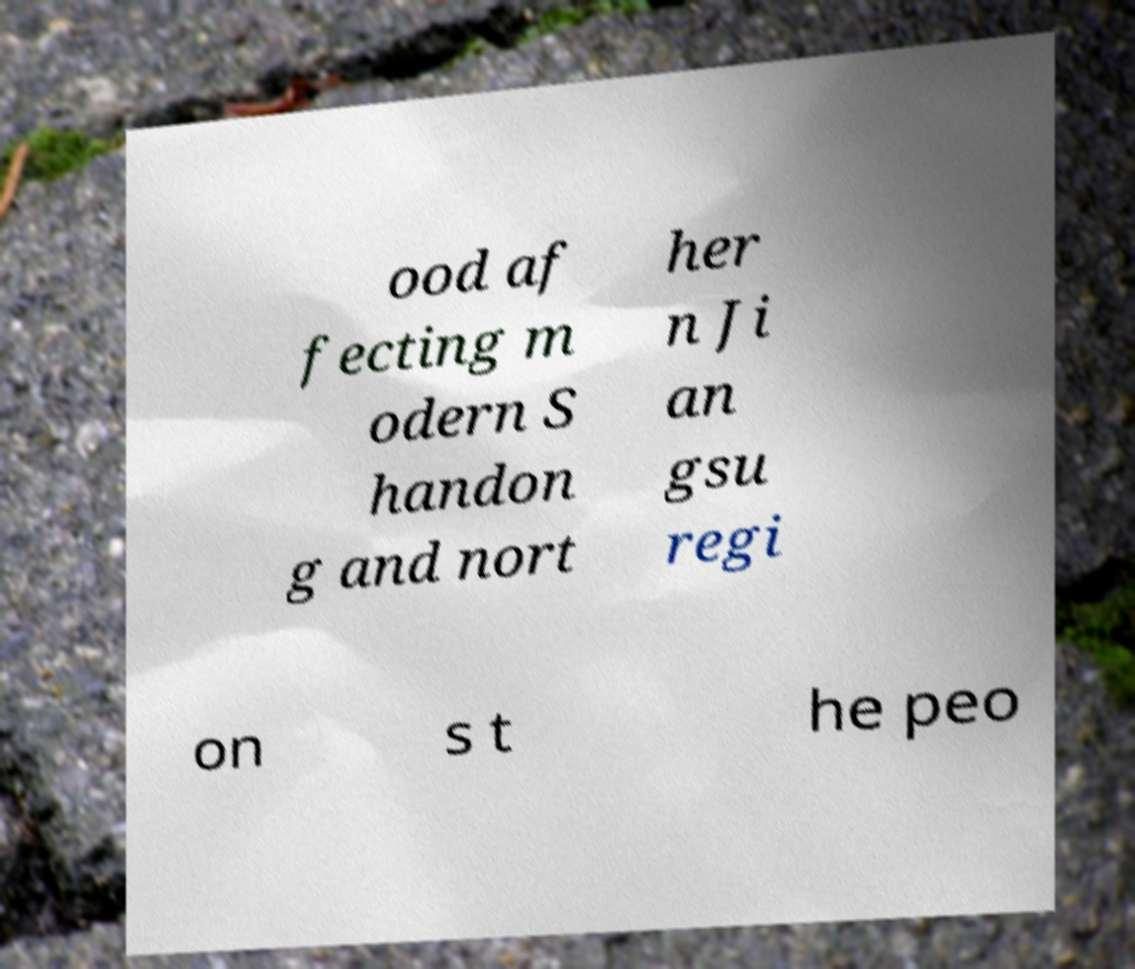There's text embedded in this image that I need extracted. Can you transcribe it verbatim? ood af fecting m odern S handon g and nort her n Ji an gsu regi on s t he peo 